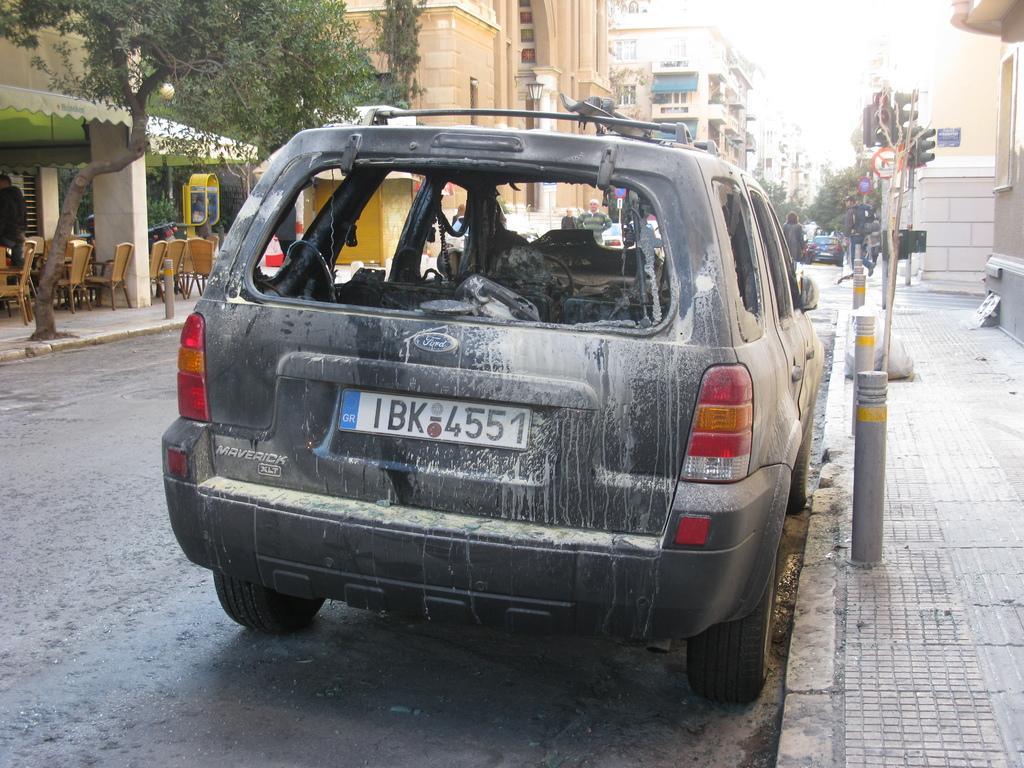Describe this image in one or two sentences. In this image I see the damaged car over here and I see the number plate on which there are alphabets and numbers and I see the road and I see number of chairs over here and I see number of buildings and I see few traffic signals over here and I see number of trees and I see few people on the path. 